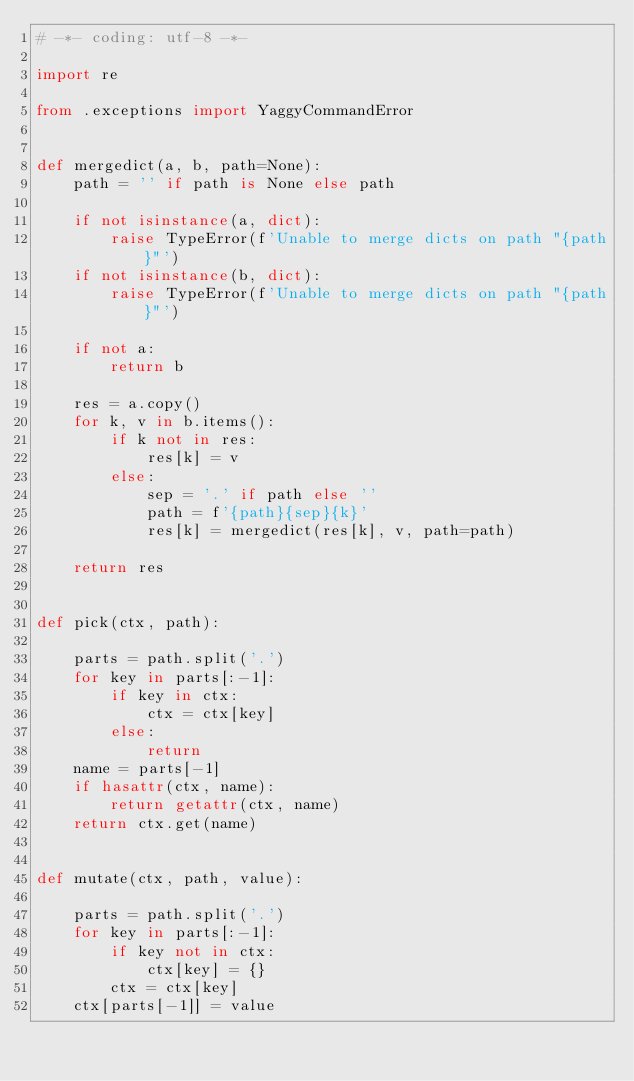Convert code to text. <code><loc_0><loc_0><loc_500><loc_500><_Python_># -*- coding: utf-8 -*-

import re

from .exceptions import YaggyCommandError


def mergedict(a, b, path=None):
    path = '' if path is None else path

    if not isinstance(a, dict):
        raise TypeError(f'Unable to merge dicts on path "{path}"')
    if not isinstance(b, dict):
        raise TypeError(f'Unable to merge dicts on path "{path}"')

    if not a:
        return b

    res = a.copy()
    for k, v in b.items():
        if k not in res:
            res[k] = v
        else:
            sep = '.' if path else ''
            path = f'{path}{sep}{k}'
            res[k] = mergedict(res[k], v, path=path)

    return res


def pick(ctx, path):

    parts = path.split('.')
    for key in parts[:-1]:
        if key in ctx:
            ctx = ctx[key]
        else:
            return
    name = parts[-1]
    if hasattr(ctx, name):
        return getattr(ctx, name)
    return ctx.get(name)


def mutate(ctx, path, value):

    parts = path.split('.')
    for key in parts[:-1]:
        if key not in ctx:
            ctx[key] = {}
        ctx = ctx[key]
    ctx[parts[-1]] = value
</code> 